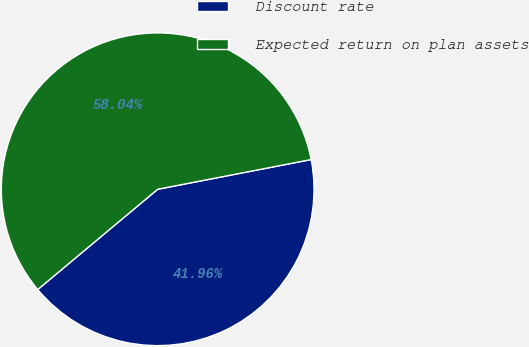Convert chart. <chart><loc_0><loc_0><loc_500><loc_500><pie_chart><fcel>Discount rate<fcel>Expected return on plan assets<nl><fcel>41.96%<fcel>58.04%<nl></chart> 